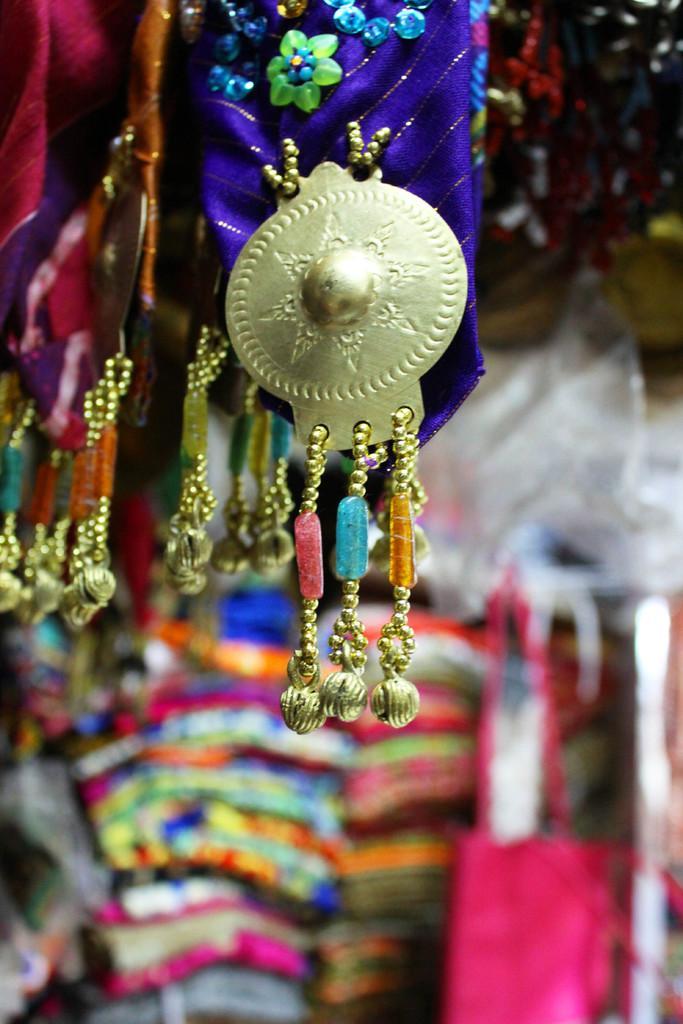Please provide a concise description of this image. In this image I can see it looks like a decorative items that are attached to the clothes. 